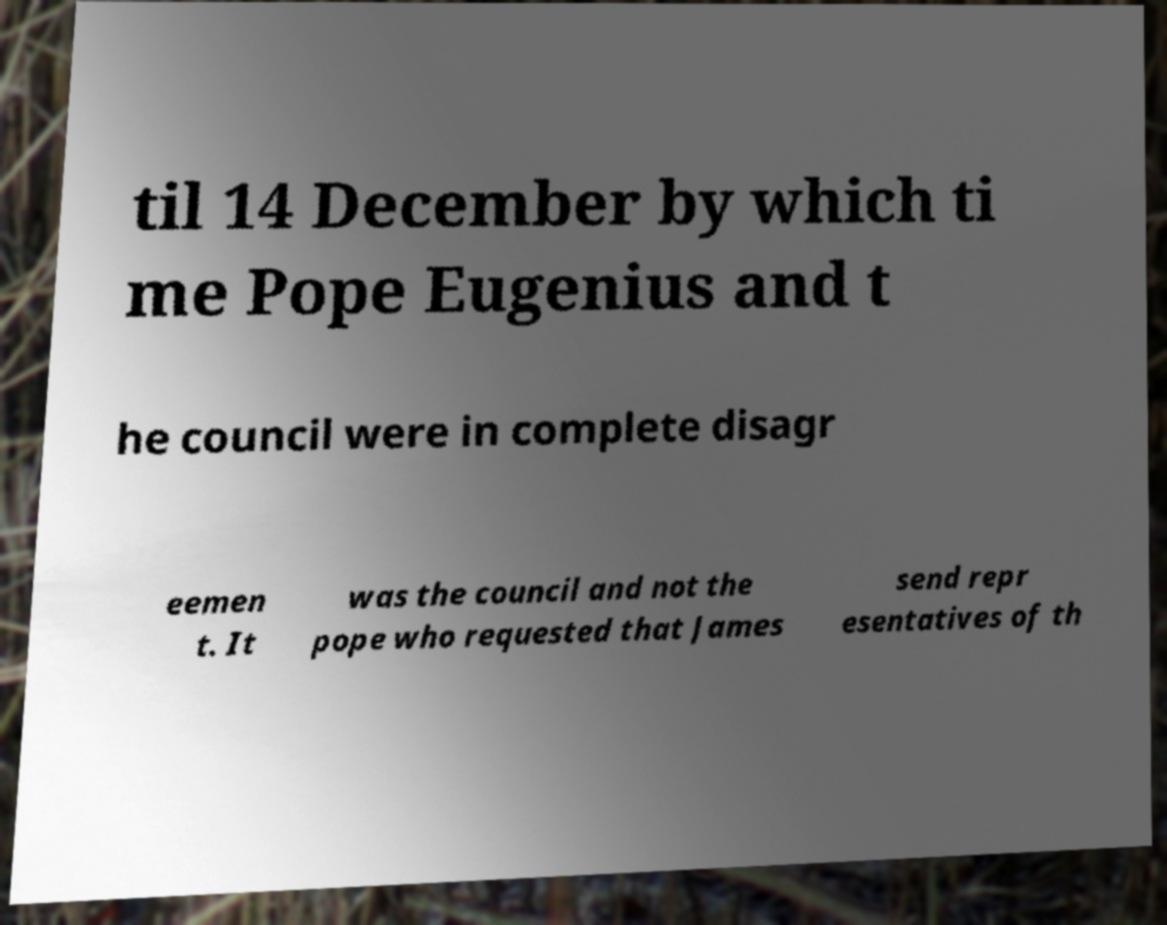Please identify and transcribe the text found in this image. til 14 December by which ti me Pope Eugenius and t he council were in complete disagr eemen t. It was the council and not the pope who requested that James send repr esentatives of th 